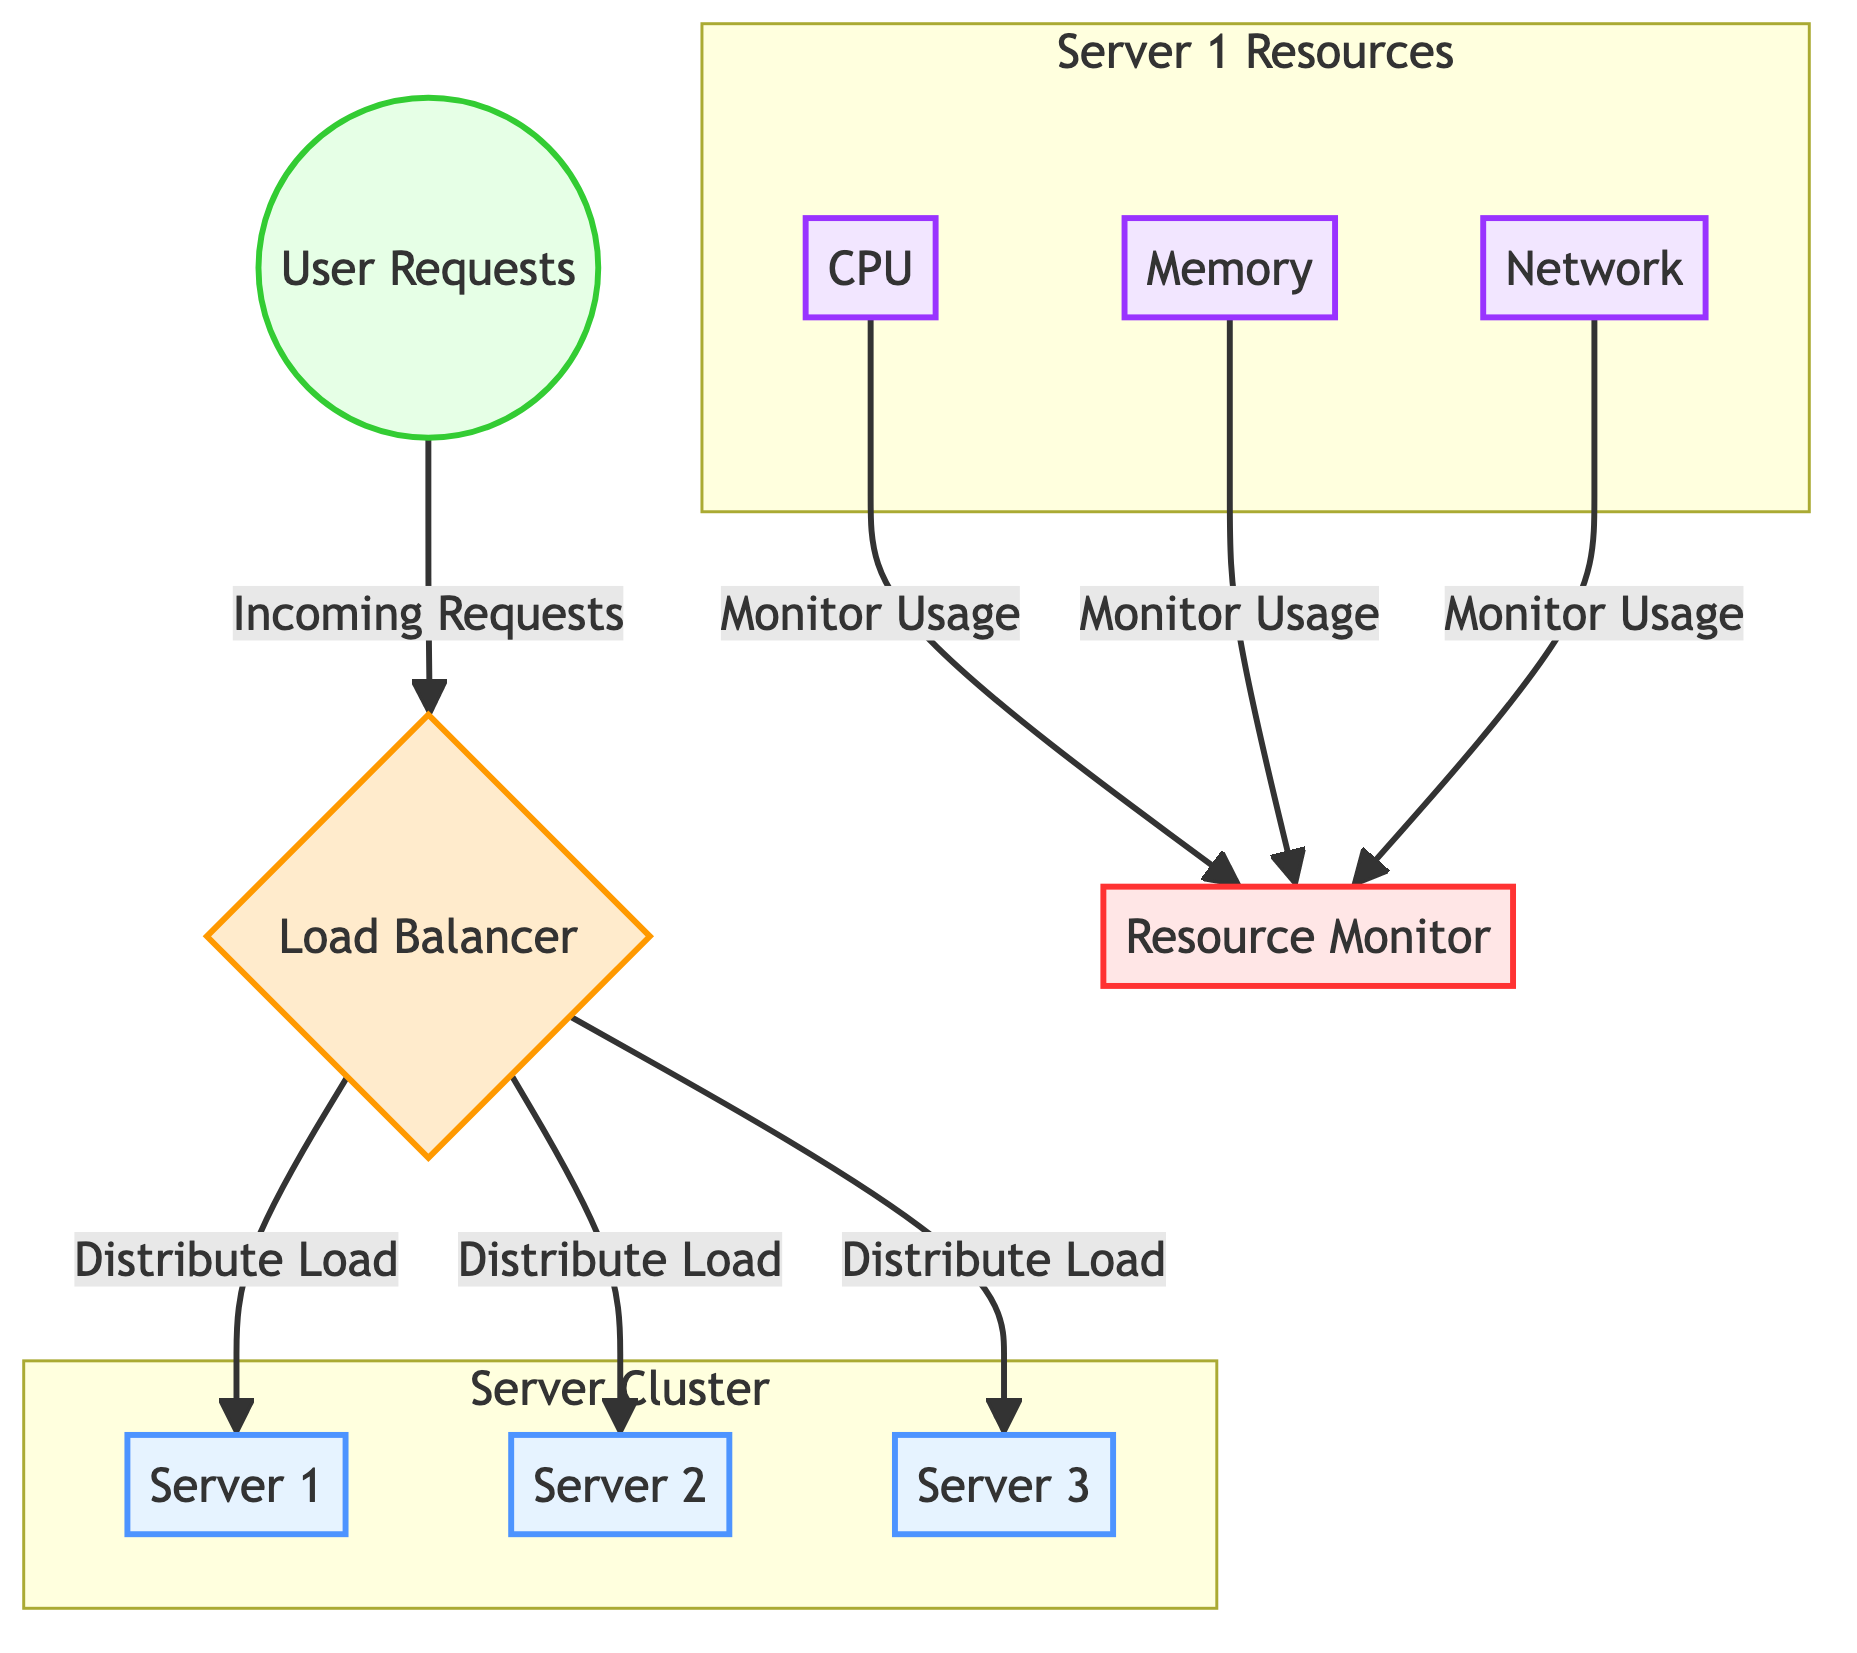What are the nodes in the server cluster? The diagram specifies three nodes in the server cluster: Server 1, Server 2, and Server 3. These are clearly labeled within the "Server Cluster" subgraph.
Answer: Server 1, Server 2, Server 3 How many resource types are monitored for Server 1? The diagram shows three types of resources that are monitored for Server 1: CPU, Memory, and Network, as shown within the "Server 1 Resources" subgraph.
Answer: 3 What role does the load balancer play in the diagram? The load balancer is responsible for distributing incoming user requests to the servers in the cluster. This functionality is illustrated by the arrows connecting user requests to the load balancer and then to the servers.
Answer: Distribute Load Which system component monitors resource usage? The Resource Monitor is explicitly stated in the diagram to monitor the resource usage of CPU, Memory, and Network, with connections indicating this monitoring role.
Answer: Resource Monitor How many servers are there in total according to the diagram? The diagram indicates that there are three servers listed in the server cluster: Server 1, Server 2, and Server 3, which can be counted from the labeled nodes within the subgraph.
Answer: 3 How do user requests interact with the load balancer? User requests are depicted as incoming requests that flow into the load balancer, which then distributes the load to the servers, as indicated by directional arrows.
Answer: Incoming Requests Which resources are monitored from Server 1? The diagram details that CPU, Memory, and Network are the resources monitored from Server 1, as represented within the dedicated resource subgraph.
Answer: CPU, Memory, Network What does the arrow between CPU and Resource Monitor indicate? The arrow signifies that the Resource Monitor is actively monitoring the usage of the CPU. This is part of the overall monitoring relationship between server resources and the resource monitoring system depicted in the diagram.
Answer: Monitor Usage What is the main system node in this diagram? The load balancer serves as the main system node, as it is central to managing how user requests are handled and distributed to the servers.
Answer: Load Balancer 